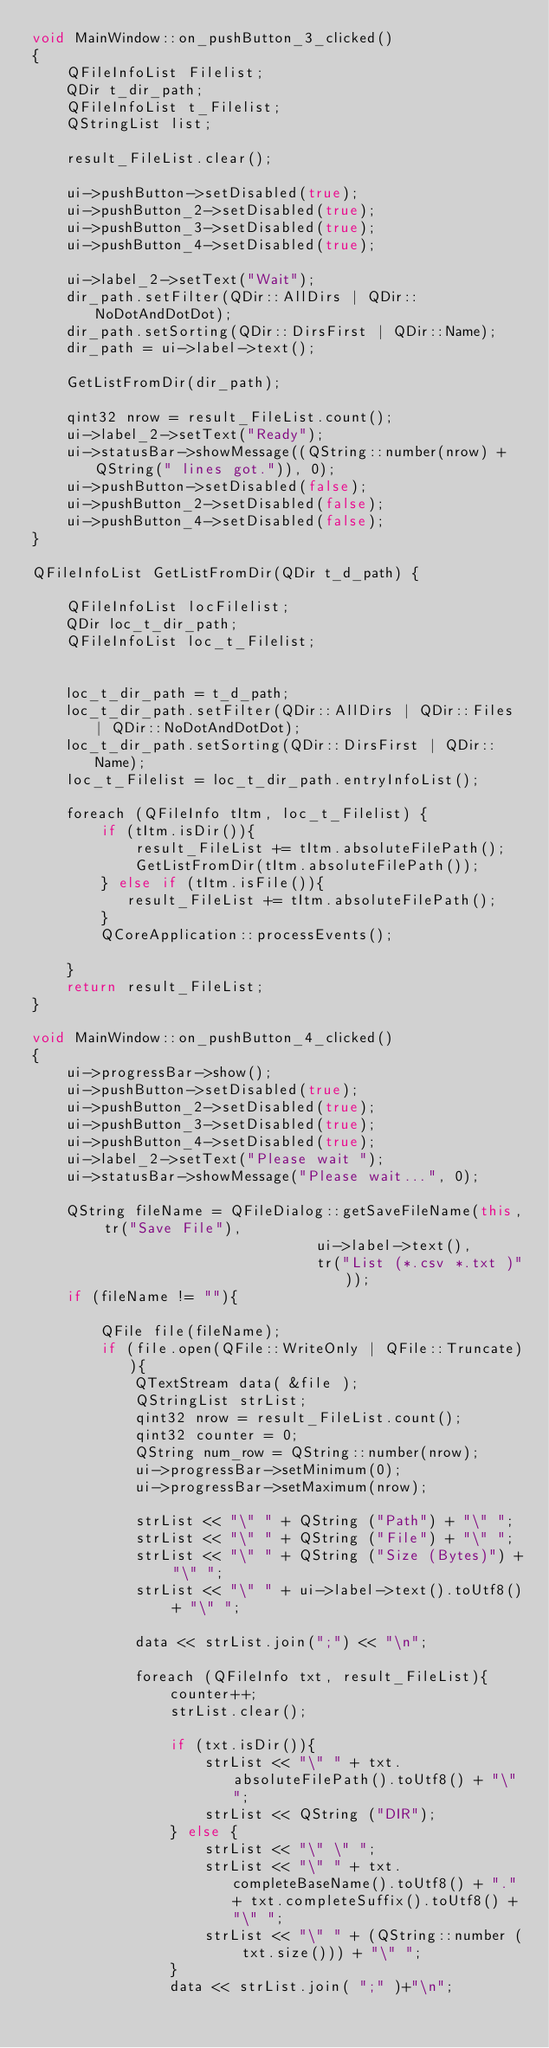<code> <loc_0><loc_0><loc_500><loc_500><_C++_>void MainWindow::on_pushButton_3_clicked()
{
    QFileInfoList Filelist;
    QDir t_dir_path;
    QFileInfoList t_Filelist;
    QStringList list;

    result_FileList.clear();

    ui->pushButton->setDisabled(true);
    ui->pushButton_2->setDisabled(true);
    ui->pushButton_3->setDisabled(true);
    ui->pushButton_4->setDisabled(true);

    ui->label_2->setText("Wait");
    dir_path.setFilter(QDir::AllDirs | QDir::NoDotAndDotDot);
    dir_path.setSorting(QDir::DirsFirst | QDir::Name);
    dir_path = ui->label->text();

    GetListFromDir(dir_path);

    qint32 nrow = result_FileList.count();
    ui->label_2->setText("Ready");
    ui->statusBar->showMessage((QString::number(nrow) + QString(" lines got.")), 0);
    ui->pushButton->setDisabled(false);
    ui->pushButton_2->setDisabled(false);
    ui->pushButton_4->setDisabled(false);
}

QFileInfoList GetListFromDir(QDir t_d_path) {

    QFileInfoList locFilelist;
    QDir loc_t_dir_path;
    QFileInfoList loc_t_Filelist;


    loc_t_dir_path = t_d_path;
    loc_t_dir_path.setFilter(QDir::AllDirs | QDir::Files | QDir::NoDotAndDotDot);
    loc_t_dir_path.setSorting(QDir::DirsFirst | QDir::Name);
    loc_t_Filelist = loc_t_dir_path.entryInfoList();

    foreach (QFileInfo tItm, loc_t_Filelist) {
        if (tItm.isDir()){
            result_FileList += tItm.absoluteFilePath();
            GetListFromDir(tItm.absoluteFilePath());
        } else if (tItm.isFile()){
           result_FileList += tItm.absoluteFilePath();
        }
        QCoreApplication::processEvents();

    }
    return result_FileList;
}

void MainWindow::on_pushButton_4_clicked()
{
    ui->progressBar->show();
    ui->pushButton->setDisabled(true);
    ui->pushButton_2->setDisabled(true);
    ui->pushButton_3->setDisabled(true);
    ui->pushButton_4->setDisabled(true);
    ui->label_2->setText("Please wait ");
    ui->statusBar->showMessage("Please wait...", 0);

    QString fileName = QFileDialog::getSaveFileName(this, tr("Save File"),
                                 ui->label->text(),
                                 tr("List (*.csv *.txt )"));
    if (fileName != ""){

        QFile file(fileName);
        if (file.open(QFile::WriteOnly | QFile::Truncate)){
            QTextStream data( &file );
            QStringList strList;
            qint32 nrow = result_FileList.count();
            qint32 counter = 0;
            QString num_row = QString::number(nrow);
            ui->progressBar->setMinimum(0);
            ui->progressBar->setMaximum(nrow);

            strList << "\" " + QString ("Path") + "\" ";
            strList << "\" " + QString ("File") + "\" ";
            strList << "\" " + QString ("Size (Bytes)") + "\" ";
            strList << "\" " + ui->label->text().toUtf8() + "\" ";

            data << strList.join(";") << "\n";

            foreach (QFileInfo txt, result_FileList){
                counter++;
                strList.clear();

                if (txt.isDir()){
                    strList << "\" " + txt.absoluteFilePath().toUtf8() + "\" ";
                    strList << QString ("DIR");
                } else {
                    strList << "\" \" ";
                    strList << "\" " + txt.completeBaseName().toUtf8() + "." + txt.completeSuffix().toUtf8() + "\" ";
                    strList << "\" " + (QString::number ( txt.size())) + "\" ";
                }
                data << strList.join( ";" )+"\n";</code> 